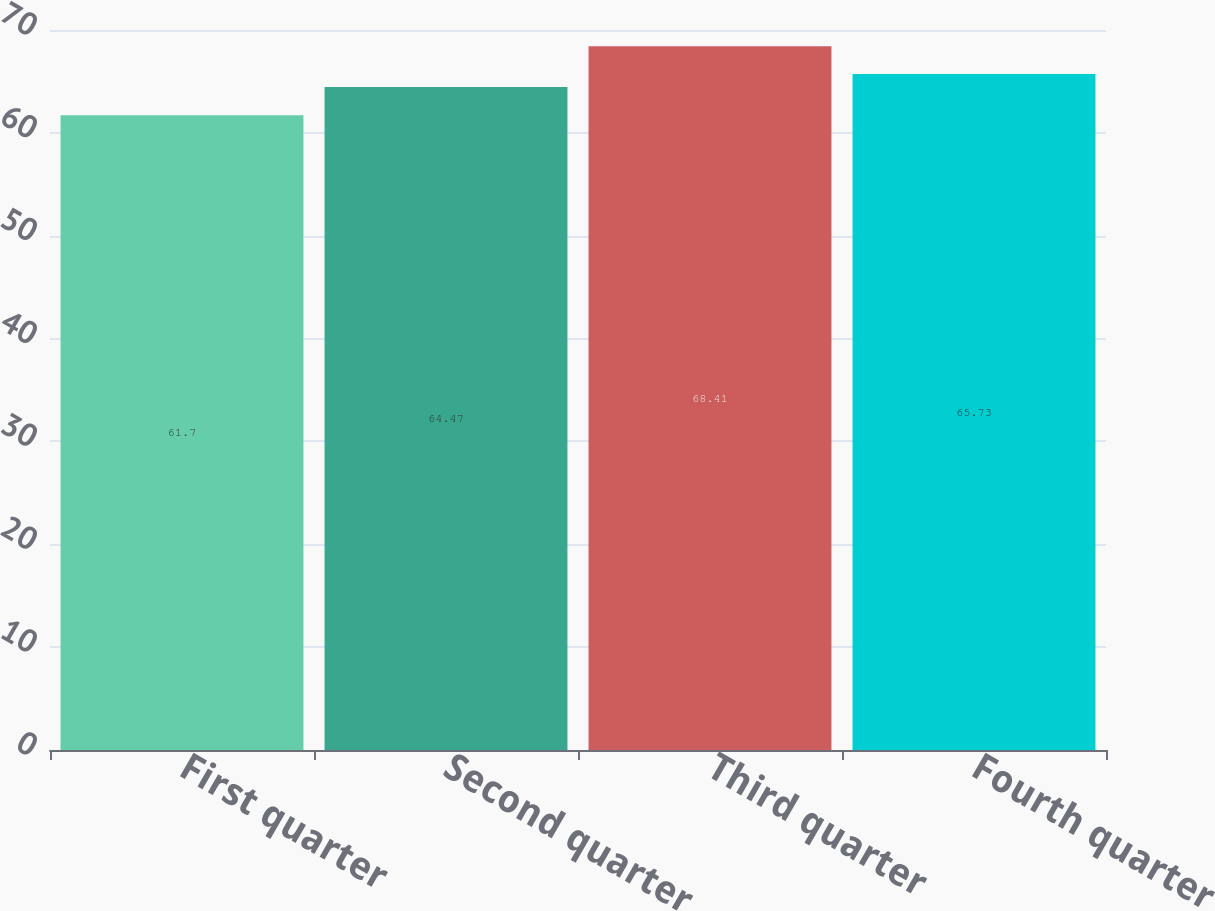<chart> <loc_0><loc_0><loc_500><loc_500><bar_chart><fcel>First quarter<fcel>Second quarter<fcel>Third quarter<fcel>Fourth quarter<nl><fcel>61.7<fcel>64.47<fcel>68.41<fcel>65.73<nl></chart> 